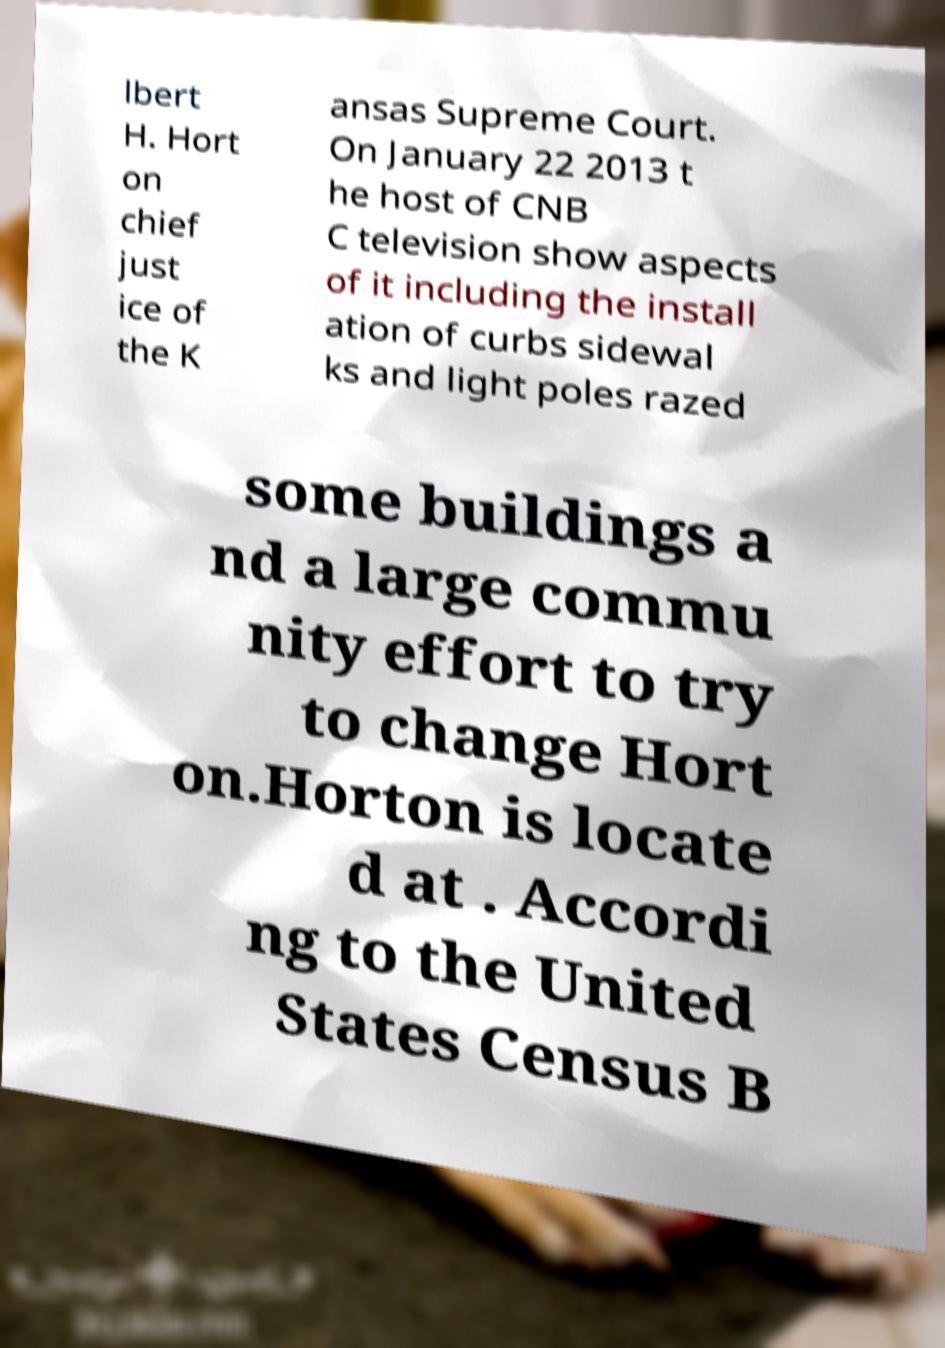I need the written content from this picture converted into text. Can you do that? lbert H. Hort on chief just ice of the K ansas Supreme Court. On January 22 2013 t he host of CNB C television show aspects of it including the install ation of curbs sidewal ks and light poles razed some buildings a nd a large commu nity effort to try to change Hort on.Horton is locate d at . Accordi ng to the United States Census B 